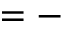Convert formula to latex. <formula><loc_0><loc_0><loc_500><loc_500>= -</formula> 